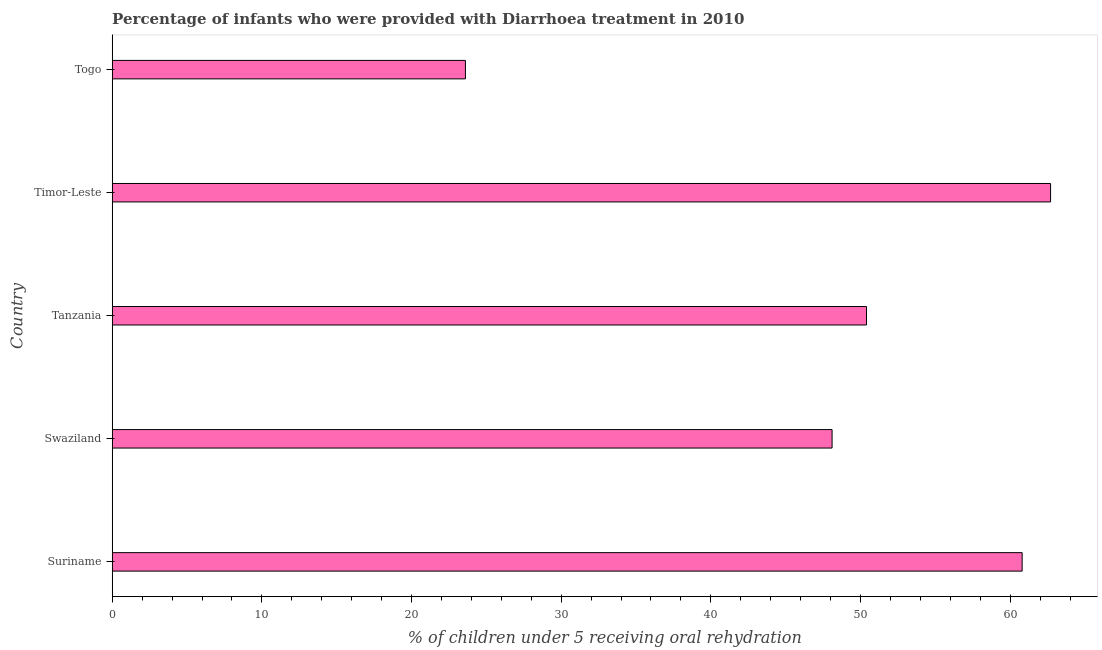Does the graph contain any zero values?
Keep it short and to the point. No. What is the title of the graph?
Your answer should be compact. Percentage of infants who were provided with Diarrhoea treatment in 2010. What is the label or title of the X-axis?
Your answer should be compact. % of children under 5 receiving oral rehydration. What is the label or title of the Y-axis?
Give a very brief answer. Country. What is the percentage of children who were provided with treatment diarrhoea in Suriname?
Your response must be concise. 60.8. Across all countries, what is the maximum percentage of children who were provided with treatment diarrhoea?
Your response must be concise. 62.7. Across all countries, what is the minimum percentage of children who were provided with treatment diarrhoea?
Give a very brief answer. 23.6. In which country was the percentage of children who were provided with treatment diarrhoea maximum?
Ensure brevity in your answer.  Timor-Leste. In which country was the percentage of children who were provided with treatment diarrhoea minimum?
Ensure brevity in your answer.  Togo. What is the sum of the percentage of children who were provided with treatment diarrhoea?
Offer a very short reply. 245.6. What is the difference between the percentage of children who were provided with treatment diarrhoea in Swaziland and Tanzania?
Ensure brevity in your answer.  -2.3. What is the average percentage of children who were provided with treatment diarrhoea per country?
Your answer should be compact. 49.12. What is the median percentage of children who were provided with treatment diarrhoea?
Provide a succinct answer. 50.4. In how many countries, is the percentage of children who were provided with treatment diarrhoea greater than 44 %?
Give a very brief answer. 4. What is the ratio of the percentage of children who were provided with treatment diarrhoea in Swaziland to that in Timor-Leste?
Give a very brief answer. 0.77. Is the percentage of children who were provided with treatment diarrhoea in Suriname less than that in Togo?
Your response must be concise. No. What is the difference between the highest and the second highest percentage of children who were provided with treatment diarrhoea?
Your answer should be very brief. 1.9. Is the sum of the percentage of children who were provided with treatment diarrhoea in Swaziland and Tanzania greater than the maximum percentage of children who were provided with treatment diarrhoea across all countries?
Ensure brevity in your answer.  Yes. What is the difference between the highest and the lowest percentage of children who were provided with treatment diarrhoea?
Your answer should be very brief. 39.1. How many bars are there?
Give a very brief answer. 5. Are all the bars in the graph horizontal?
Ensure brevity in your answer.  Yes. What is the difference between two consecutive major ticks on the X-axis?
Ensure brevity in your answer.  10. Are the values on the major ticks of X-axis written in scientific E-notation?
Ensure brevity in your answer.  No. What is the % of children under 5 receiving oral rehydration of Suriname?
Your response must be concise. 60.8. What is the % of children under 5 receiving oral rehydration of Swaziland?
Provide a succinct answer. 48.1. What is the % of children under 5 receiving oral rehydration in Tanzania?
Offer a very short reply. 50.4. What is the % of children under 5 receiving oral rehydration in Timor-Leste?
Give a very brief answer. 62.7. What is the % of children under 5 receiving oral rehydration in Togo?
Provide a succinct answer. 23.6. What is the difference between the % of children under 5 receiving oral rehydration in Suriname and Swaziland?
Keep it short and to the point. 12.7. What is the difference between the % of children under 5 receiving oral rehydration in Suriname and Togo?
Your answer should be very brief. 37.2. What is the difference between the % of children under 5 receiving oral rehydration in Swaziland and Timor-Leste?
Make the answer very short. -14.6. What is the difference between the % of children under 5 receiving oral rehydration in Swaziland and Togo?
Provide a short and direct response. 24.5. What is the difference between the % of children under 5 receiving oral rehydration in Tanzania and Togo?
Offer a terse response. 26.8. What is the difference between the % of children under 5 receiving oral rehydration in Timor-Leste and Togo?
Keep it short and to the point. 39.1. What is the ratio of the % of children under 5 receiving oral rehydration in Suriname to that in Swaziland?
Make the answer very short. 1.26. What is the ratio of the % of children under 5 receiving oral rehydration in Suriname to that in Tanzania?
Provide a succinct answer. 1.21. What is the ratio of the % of children under 5 receiving oral rehydration in Suriname to that in Timor-Leste?
Provide a short and direct response. 0.97. What is the ratio of the % of children under 5 receiving oral rehydration in Suriname to that in Togo?
Your answer should be very brief. 2.58. What is the ratio of the % of children under 5 receiving oral rehydration in Swaziland to that in Tanzania?
Provide a succinct answer. 0.95. What is the ratio of the % of children under 5 receiving oral rehydration in Swaziland to that in Timor-Leste?
Offer a terse response. 0.77. What is the ratio of the % of children under 5 receiving oral rehydration in Swaziland to that in Togo?
Give a very brief answer. 2.04. What is the ratio of the % of children under 5 receiving oral rehydration in Tanzania to that in Timor-Leste?
Provide a succinct answer. 0.8. What is the ratio of the % of children under 5 receiving oral rehydration in Tanzania to that in Togo?
Ensure brevity in your answer.  2.14. What is the ratio of the % of children under 5 receiving oral rehydration in Timor-Leste to that in Togo?
Your answer should be compact. 2.66. 